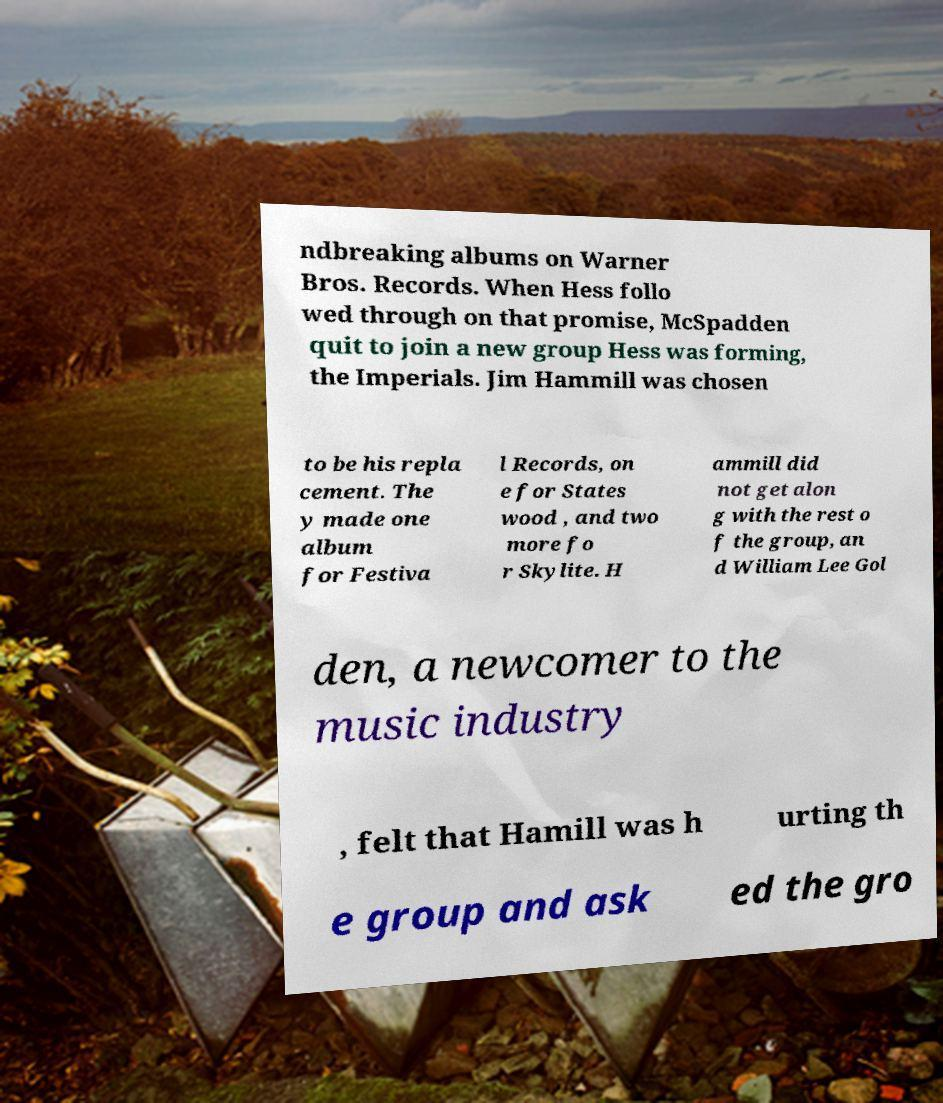For documentation purposes, I need the text within this image transcribed. Could you provide that? ndbreaking albums on Warner Bros. Records. When Hess follo wed through on that promise, McSpadden quit to join a new group Hess was forming, the Imperials. Jim Hammill was chosen to be his repla cement. The y made one album for Festiva l Records, on e for States wood , and two more fo r Skylite. H ammill did not get alon g with the rest o f the group, an d William Lee Gol den, a newcomer to the music industry , felt that Hamill was h urting th e group and ask ed the gro 